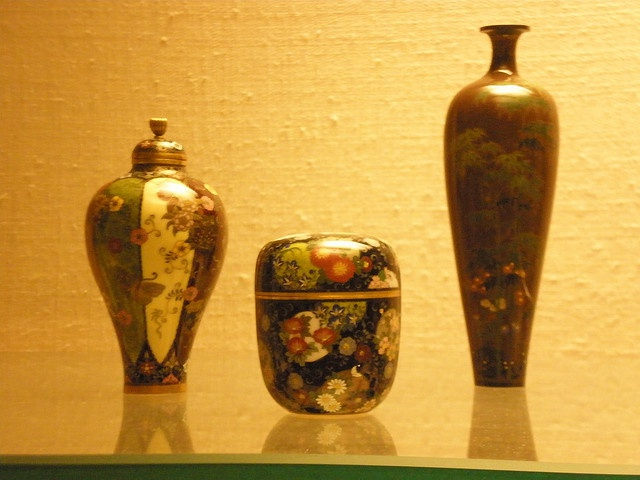Describe the objects in this image and their specific colors. I can see vase in orange, maroon, brown, and black tones, vase in orange, maroon, and olive tones, and vase in orange, maroon, olive, and black tones in this image. 